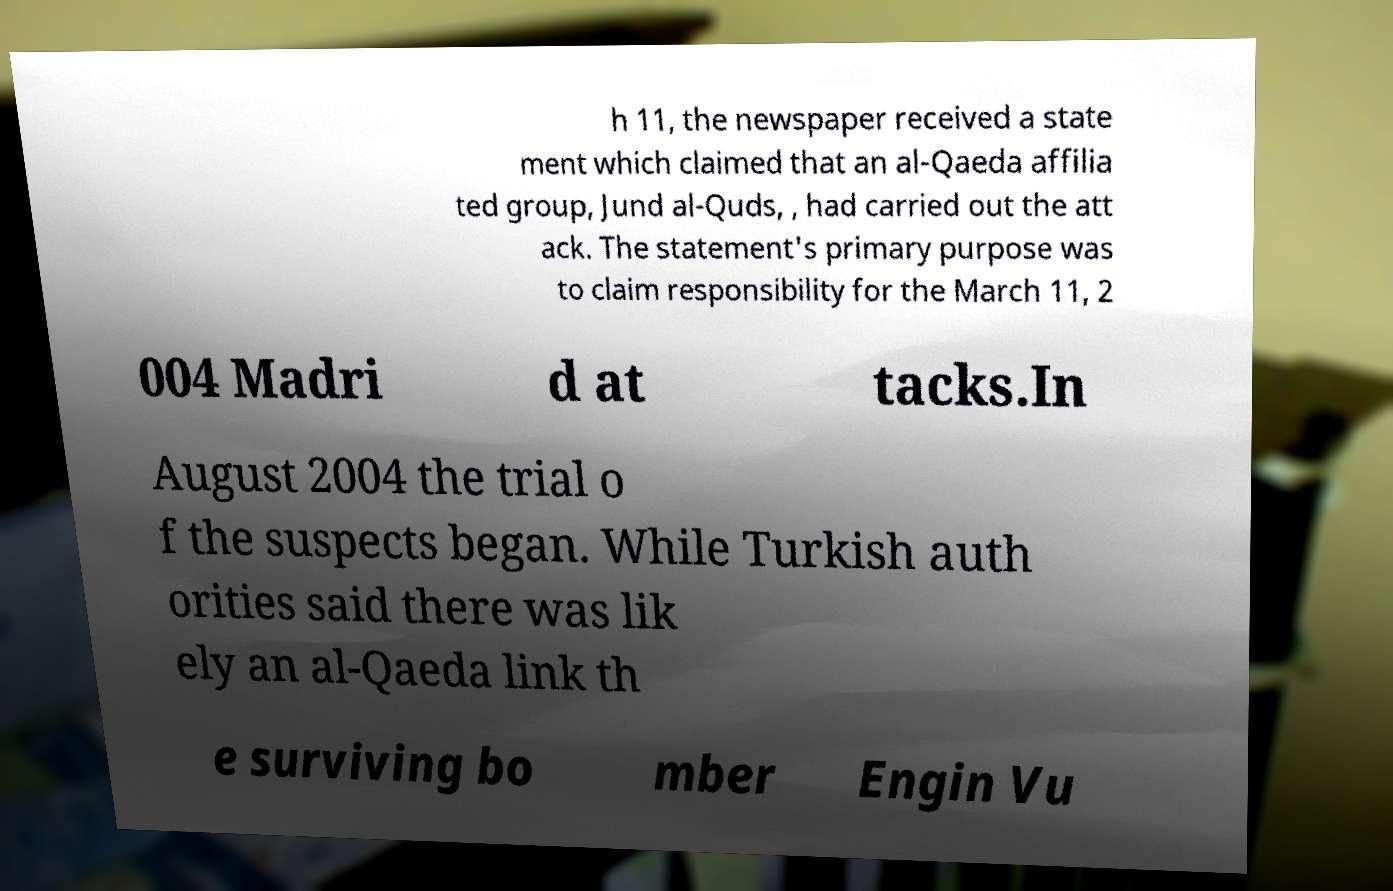Please read and relay the text visible in this image. What does it say? h 11, the newspaper received a state ment which claimed that an al-Qaeda affilia ted group, Jund al-Quds, , had carried out the att ack. The statement's primary purpose was to claim responsibility for the March 11, 2 004 Madri d at tacks.In August 2004 the trial o f the suspects began. While Turkish auth orities said there was lik ely an al-Qaeda link th e surviving bo mber Engin Vu 